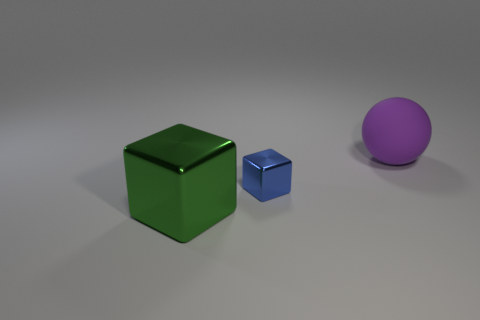Is there anything else that has the same size as the blue block?
Make the answer very short. No. Is there any other thing that is the same material as the big sphere?
Provide a succinct answer. No. Is there anything else that is the same shape as the purple thing?
Make the answer very short. No. How many cylinders are small metallic objects or purple metal objects?
Your response must be concise. 0. What number of other objects are there of the same material as the purple sphere?
Provide a succinct answer. 0. There is a large object to the left of the big purple rubber sphere; what is its shape?
Provide a succinct answer. Cube. The cube in front of the shiny cube that is behind the big block is made of what material?
Keep it short and to the point. Metal. Is the number of metal blocks right of the large block greater than the number of large cyan matte balls?
Give a very brief answer. Yes. What number of other objects are the same color as the large cube?
Provide a succinct answer. 0. The metal object that is the same size as the purple matte ball is what shape?
Provide a succinct answer. Cube. 